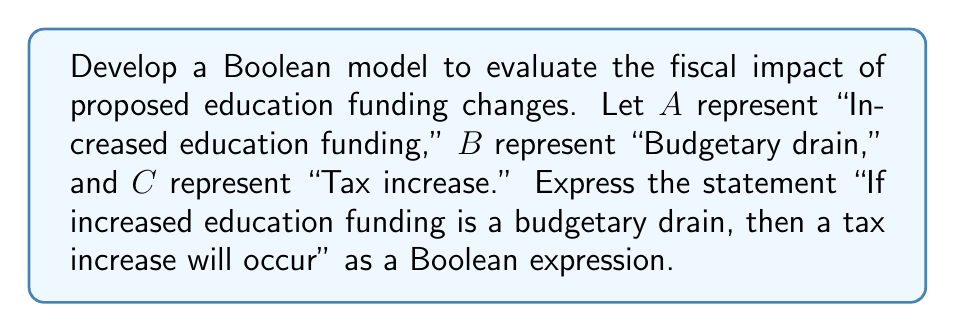What is the answer to this math problem? Let's approach this step-by-step:

1) First, we need to identify the logical components of the statement:
   - "Increased education funding" is represented by $A$
   - "Budgetary drain" is represented by $B$
   - "Tax increase" is represented by $C$

2) The statement "If increased education funding is a budgetary drain, then a tax increase will occur" is an implication.

3) In Boolean algebra, an implication $P \implies Q$ can be expressed as $\neg P \lor Q$.

4) In our case, the antecedent (P) is "Increased education funding is a budgetary drain," which can be expressed as $A \land B$.

5) The consequent (Q) is "Tax increase will occur," which is simply $C$.

6) Therefore, our implication becomes:
   $\neg(A \land B) \lor C$

7) Using De Morgan's law, we can further simplify $\neg(A \land B)$ to $\neg A \lor \neg B$

8) Thus, our final Boolean expression is:
   $(\neg A \lor \neg B) \lor C$

This expression evaluates to true in all cases except when $A$ and $B$ are true (increased education funding is a budgetary drain) and $C$ is false (no tax increase occurs).
Answer: $(\neg A \lor \neg B) \lor C$ 